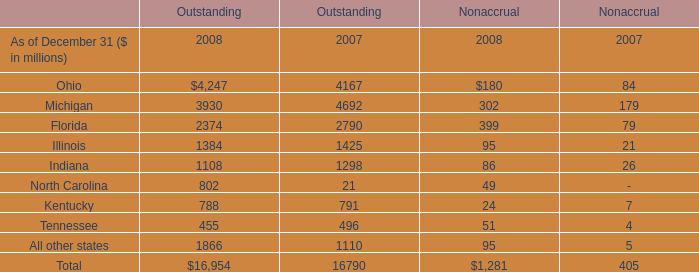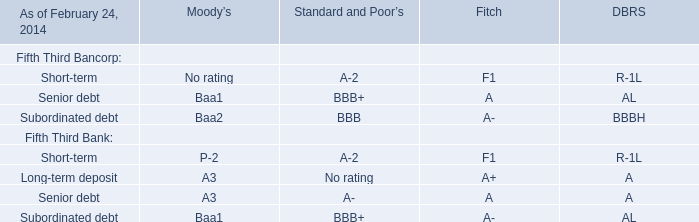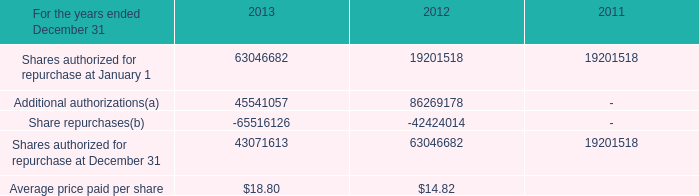What is the average amount of Shares authorized for repurchase at January 1 of 2011, and All other states of Outstanding 2008 ? 
Computations: ((19201518.0 + 1866.0) / 2)
Answer: 9601692.0. 